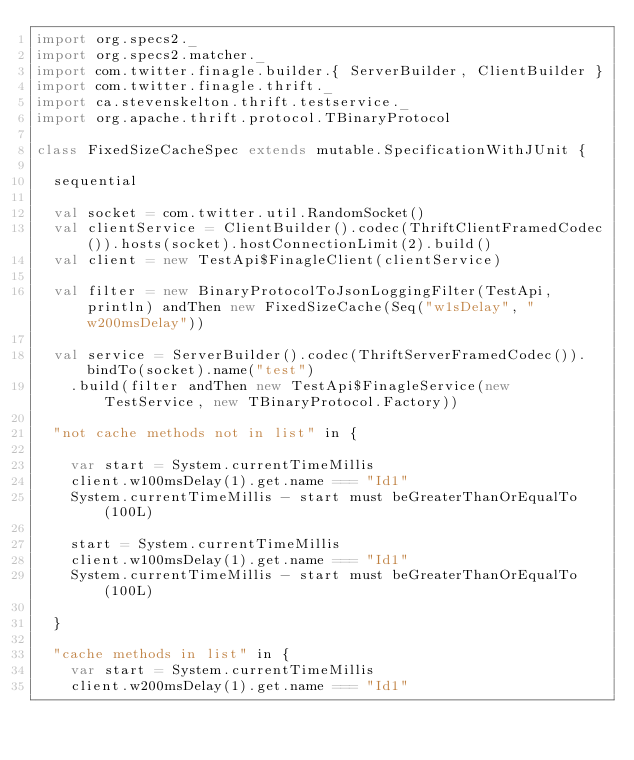Convert code to text. <code><loc_0><loc_0><loc_500><loc_500><_Scala_>import org.specs2._
import org.specs2.matcher._
import com.twitter.finagle.builder.{ ServerBuilder, ClientBuilder }
import com.twitter.finagle.thrift._
import ca.stevenskelton.thrift.testservice._
import org.apache.thrift.protocol.TBinaryProtocol

class FixedSizeCacheSpec extends mutable.SpecificationWithJUnit {

  sequential

  val socket = com.twitter.util.RandomSocket()
  val clientService = ClientBuilder().codec(ThriftClientFramedCodec()).hosts(socket).hostConnectionLimit(2).build()
  val client = new TestApi$FinagleClient(clientService)

  val filter = new BinaryProtocolToJsonLoggingFilter(TestApi, println) andThen new FixedSizeCache(Seq("w1sDelay", "w200msDelay"))

  val service = ServerBuilder().codec(ThriftServerFramedCodec()).bindTo(socket).name("test")
    .build(filter andThen new TestApi$FinagleService(new TestService, new TBinaryProtocol.Factory))

  "not cache methods not in list" in {

    var start = System.currentTimeMillis
    client.w100msDelay(1).get.name === "Id1"
    System.currentTimeMillis - start must beGreaterThanOrEqualTo(100L)

    start = System.currentTimeMillis
    client.w100msDelay(1).get.name === "Id1"
    System.currentTimeMillis - start must beGreaterThanOrEqualTo(100L)

  }

  "cache methods in list" in {
    var start = System.currentTimeMillis
    client.w200msDelay(1).get.name === "Id1"</code> 